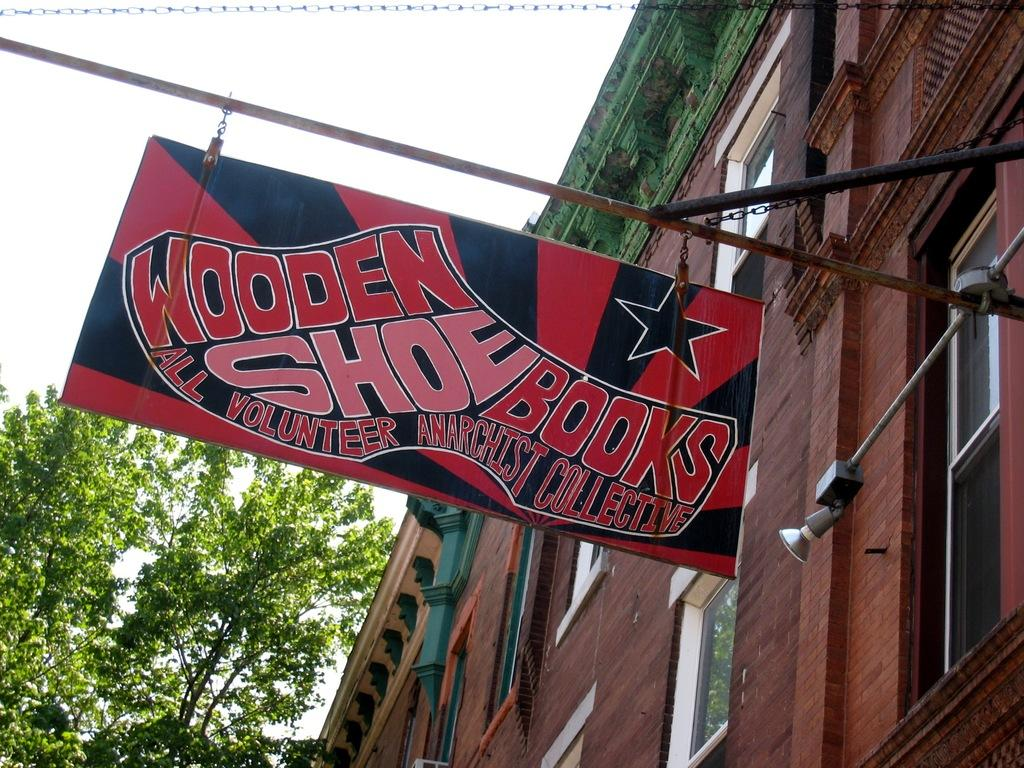What type of structure is present in the image? There is a building in the image. What feature can be observed on the building? The building has windows. What is the color of the board in the image? There is a red color board in the image. What type of vegetation is present in the image? There are trees in the image. What is written on the board? Something is written on the board. What can be seen in the image that provides illumination? There is a light visible in the image. Where is the laborer standing in the image? There is no laborer present in the image. What type of performance is taking place on the stage in the image? There is no stage present in the image. 